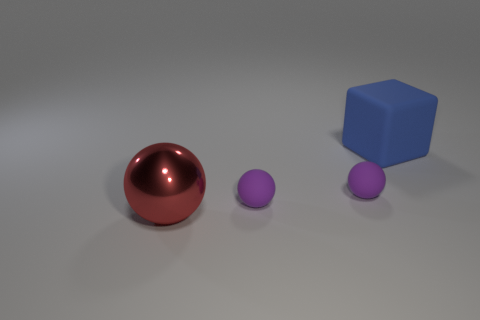Subtract all tiny rubber balls. How many balls are left? 1 Subtract all purple balls. How many balls are left? 1 Subtract all spheres. How many objects are left? 1 Subtract 2 spheres. How many spheres are left? 1 Add 3 small purple cubes. How many objects exist? 7 Subtract 0 green spheres. How many objects are left? 4 Subtract all green spheres. Subtract all gray cylinders. How many spheres are left? 3 Subtract all cyan balls. How many yellow blocks are left? 0 Subtract all purple balls. Subtract all rubber balls. How many objects are left? 0 Add 1 tiny purple objects. How many tiny purple objects are left? 3 